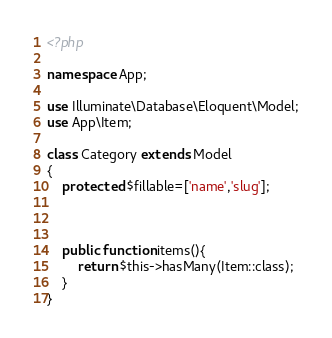<code> <loc_0><loc_0><loc_500><loc_500><_PHP_><?php

namespace App;

use Illuminate\Database\Eloquent\Model;
use App\Item;

class Category extends Model
{
    protected $fillable=['name','slug'];



    public function items(){
        return $this->hasMany(Item::class);
    }
}
</code> 